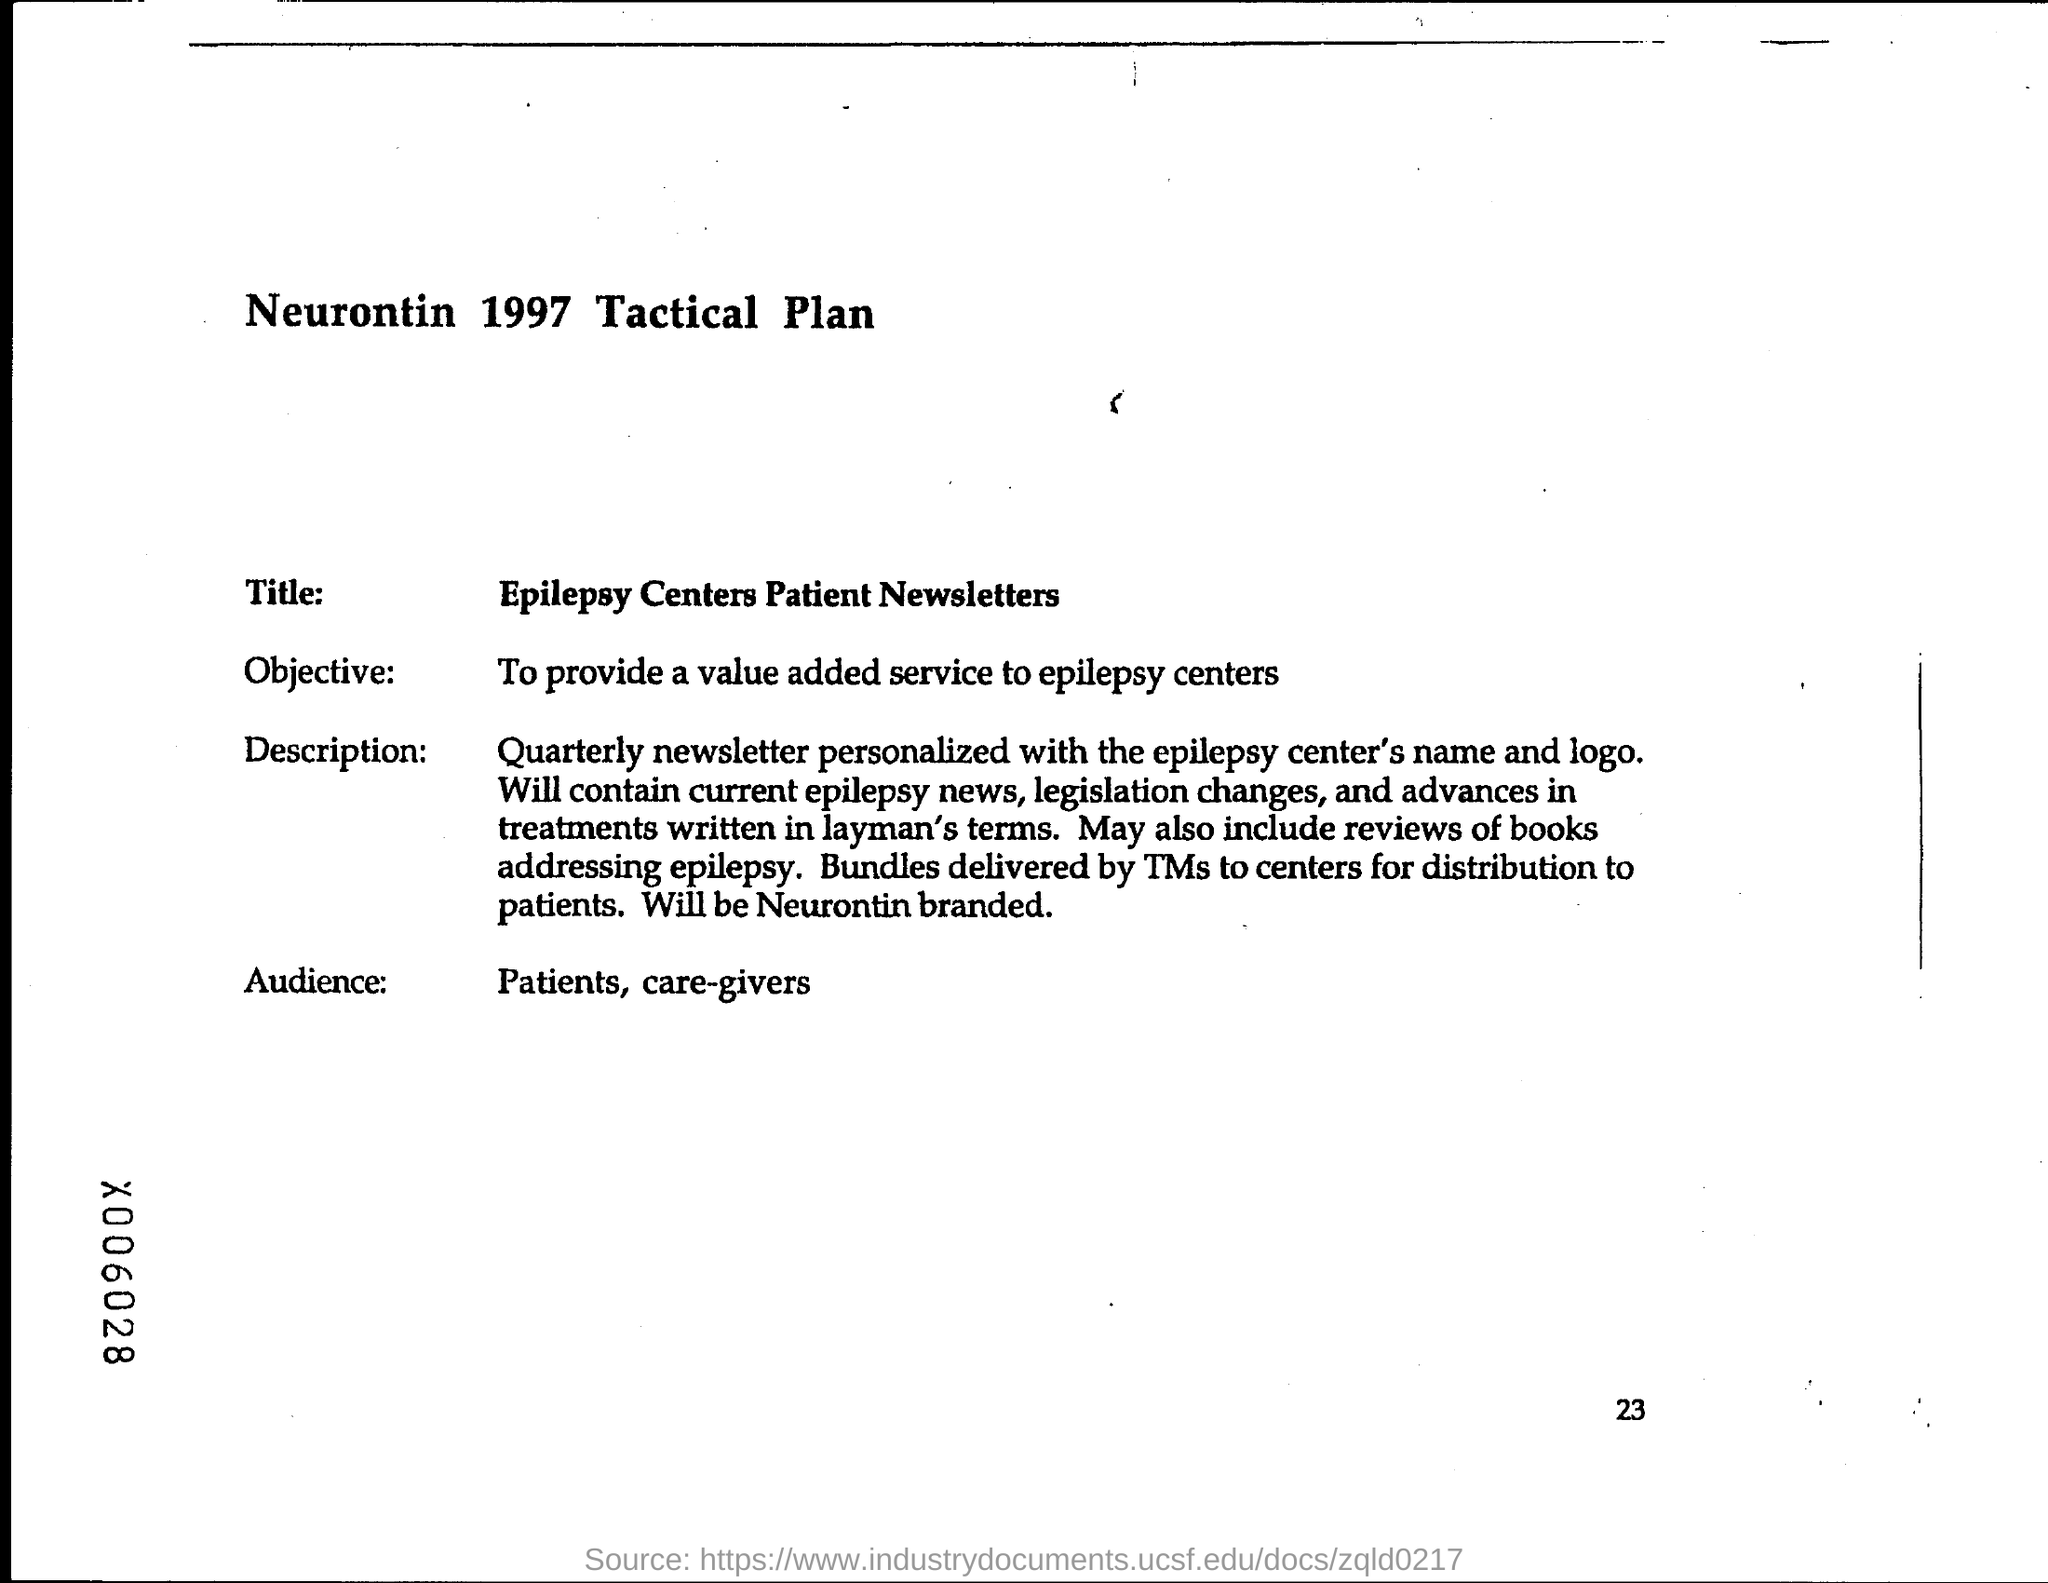Indicate a few pertinent items in this graphic. The heading at the top of the page is "Neurontin 1997 Tactical Plan. The page number at the bottom of the page is 23. 